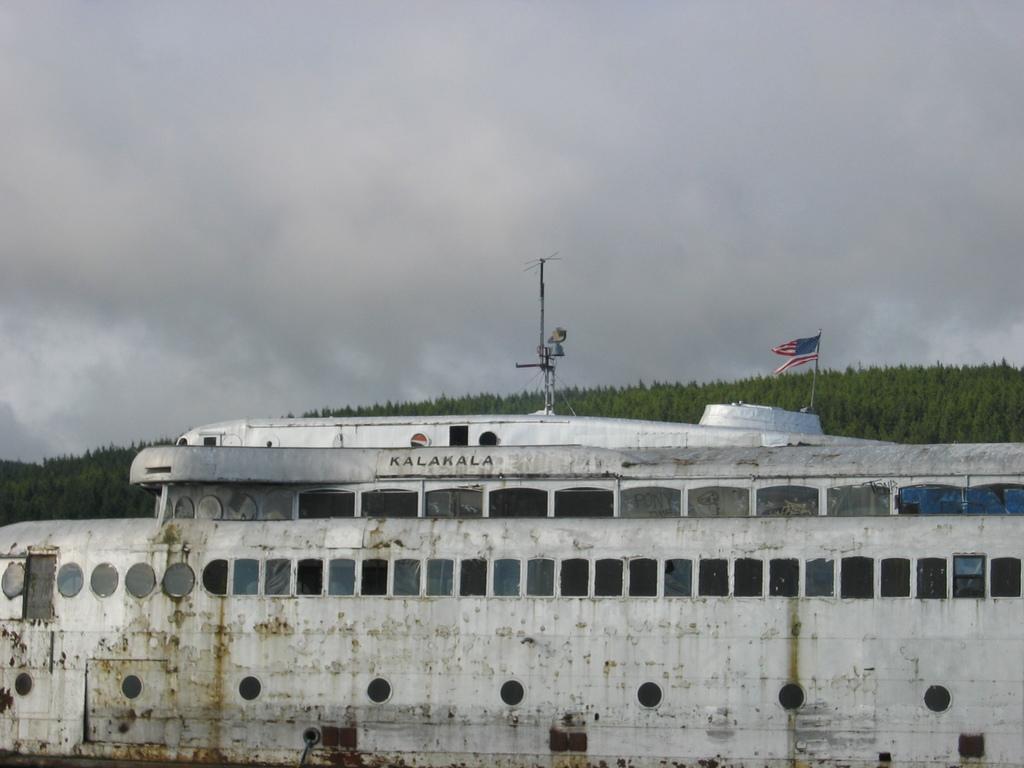Please provide a concise description of this image. In this image I can see the ship which is in white color. I can see the pole and flag on the ship. In the background I can see many trees and the cloudy sky. 